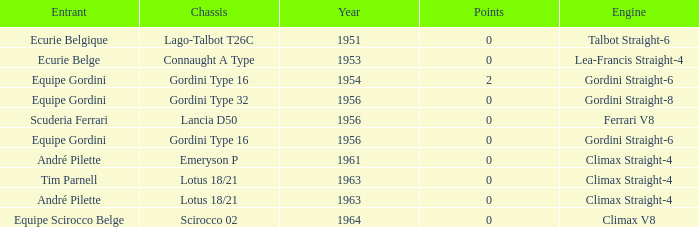Who used Gordini Straight-6 in 1956? Equipe Gordini. 